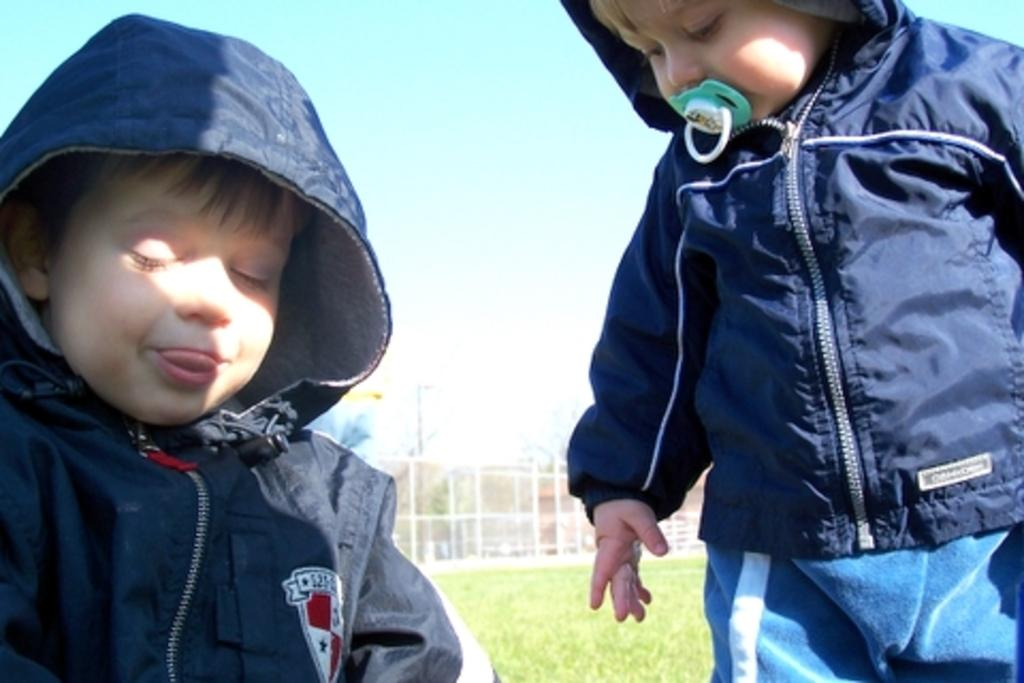How many people are in the image? There are two persons in the image. What is the position of the person on the right? The person on the right is standing. What color is the jacket worn by the person on the right? The person on the right is wearing a blue jacket. What type of vegetation is visible in the background of the image? There is grass in the background of the image. What is the color of the grass? The grass is green. What else can be seen in the background of the image? There are poles and the sky visible in the background of the image. What colors are present in the sky? The sky has blue and white colors. What type of dust can be seen covering the person on the left in the image? There is no dust present in the image, and both persons are clean and free of any dust. 